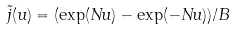<formula> <loc_0><loc_0><loc_500><loc_500>\tilde { j } ( u ) = ( \exp ( N u ) - \exp ( - N u ) ) / B</formula> 